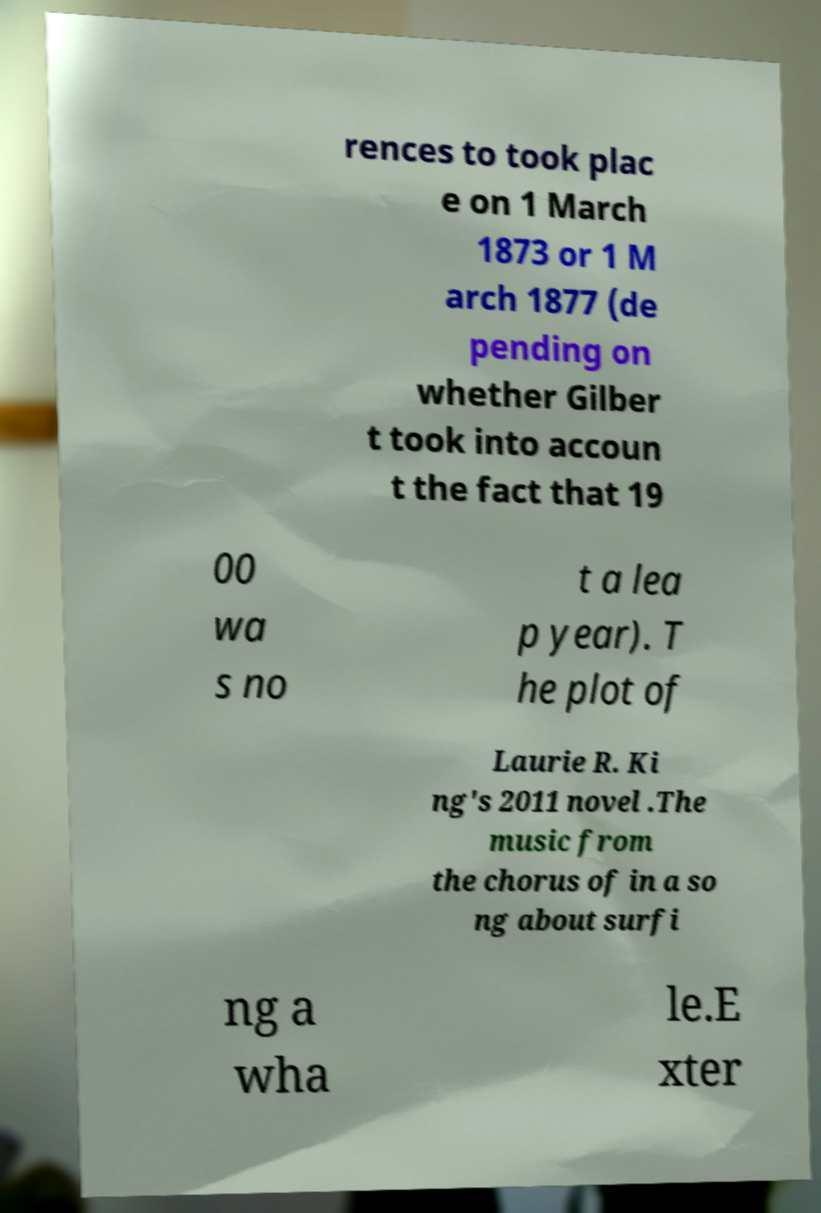Can you read and provide the text displayed in the image?This photo seems to have some interesting text. Can you extract and type it out for me? rences to took plac e on 1 March 1873 or 1 M arch 1877 (de pending on whether Gilber t took into accoun t the fact that 19 00 wa s no t a lea p year). T he plot of Laurie R. Ki ng's 2011 novel .The music from the chorus of in a so ng about surfi ng a wha le.E xter 